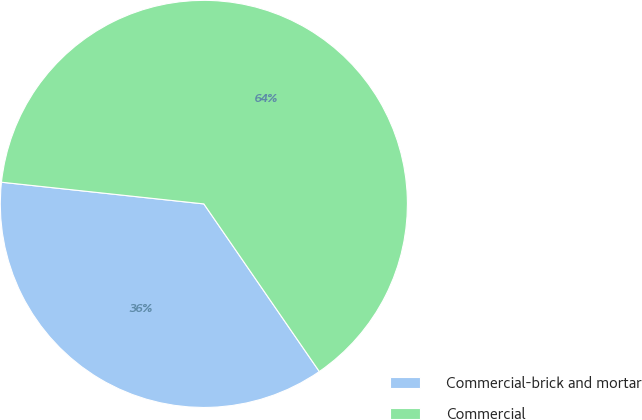Convert chart. <chart><loc_0><loc_0><loc_500><loc_500><pie_chart><fcel>Commercial-brick and mortar<fcel>Commercial<nl><fcel>36.3%<fcel>63.7%<nl></chart> 